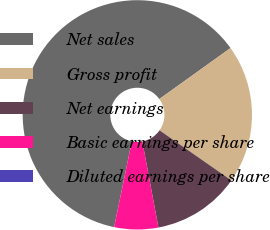<chart> <loc_0><loc_0><loc_500><loc_500><pie_chart><fcel>Net sales<fcel>Gross profit<fcel>Net earnings<fcel>Basic earnings per share<fcel>Diluted earnings per share<nl><fcel>61.86%<fcel>19.58%<fcel>12.37%<fcel>6.19%<fcel>0.0%<nl></chart> 